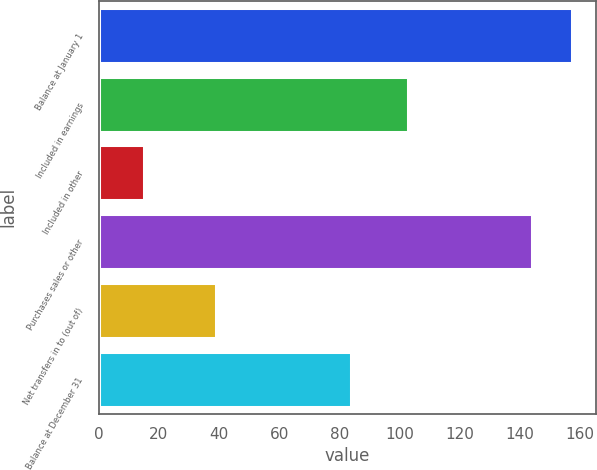Convert chart to OTSL. <chart><loc_0><loc_0><loc_500><loc_500><bar_chart><fcel>Balance at January 1<fcel>Included in earnings<fcel>Included in other<fcel>Purchases sales or other<fcel>Net transfers in to (out of)<fcel>Balance at December 31<nl><fcel>157.4<fcel>103<fcel>15<fcel>144<fcel>39<fcel>84<nl></chart> 